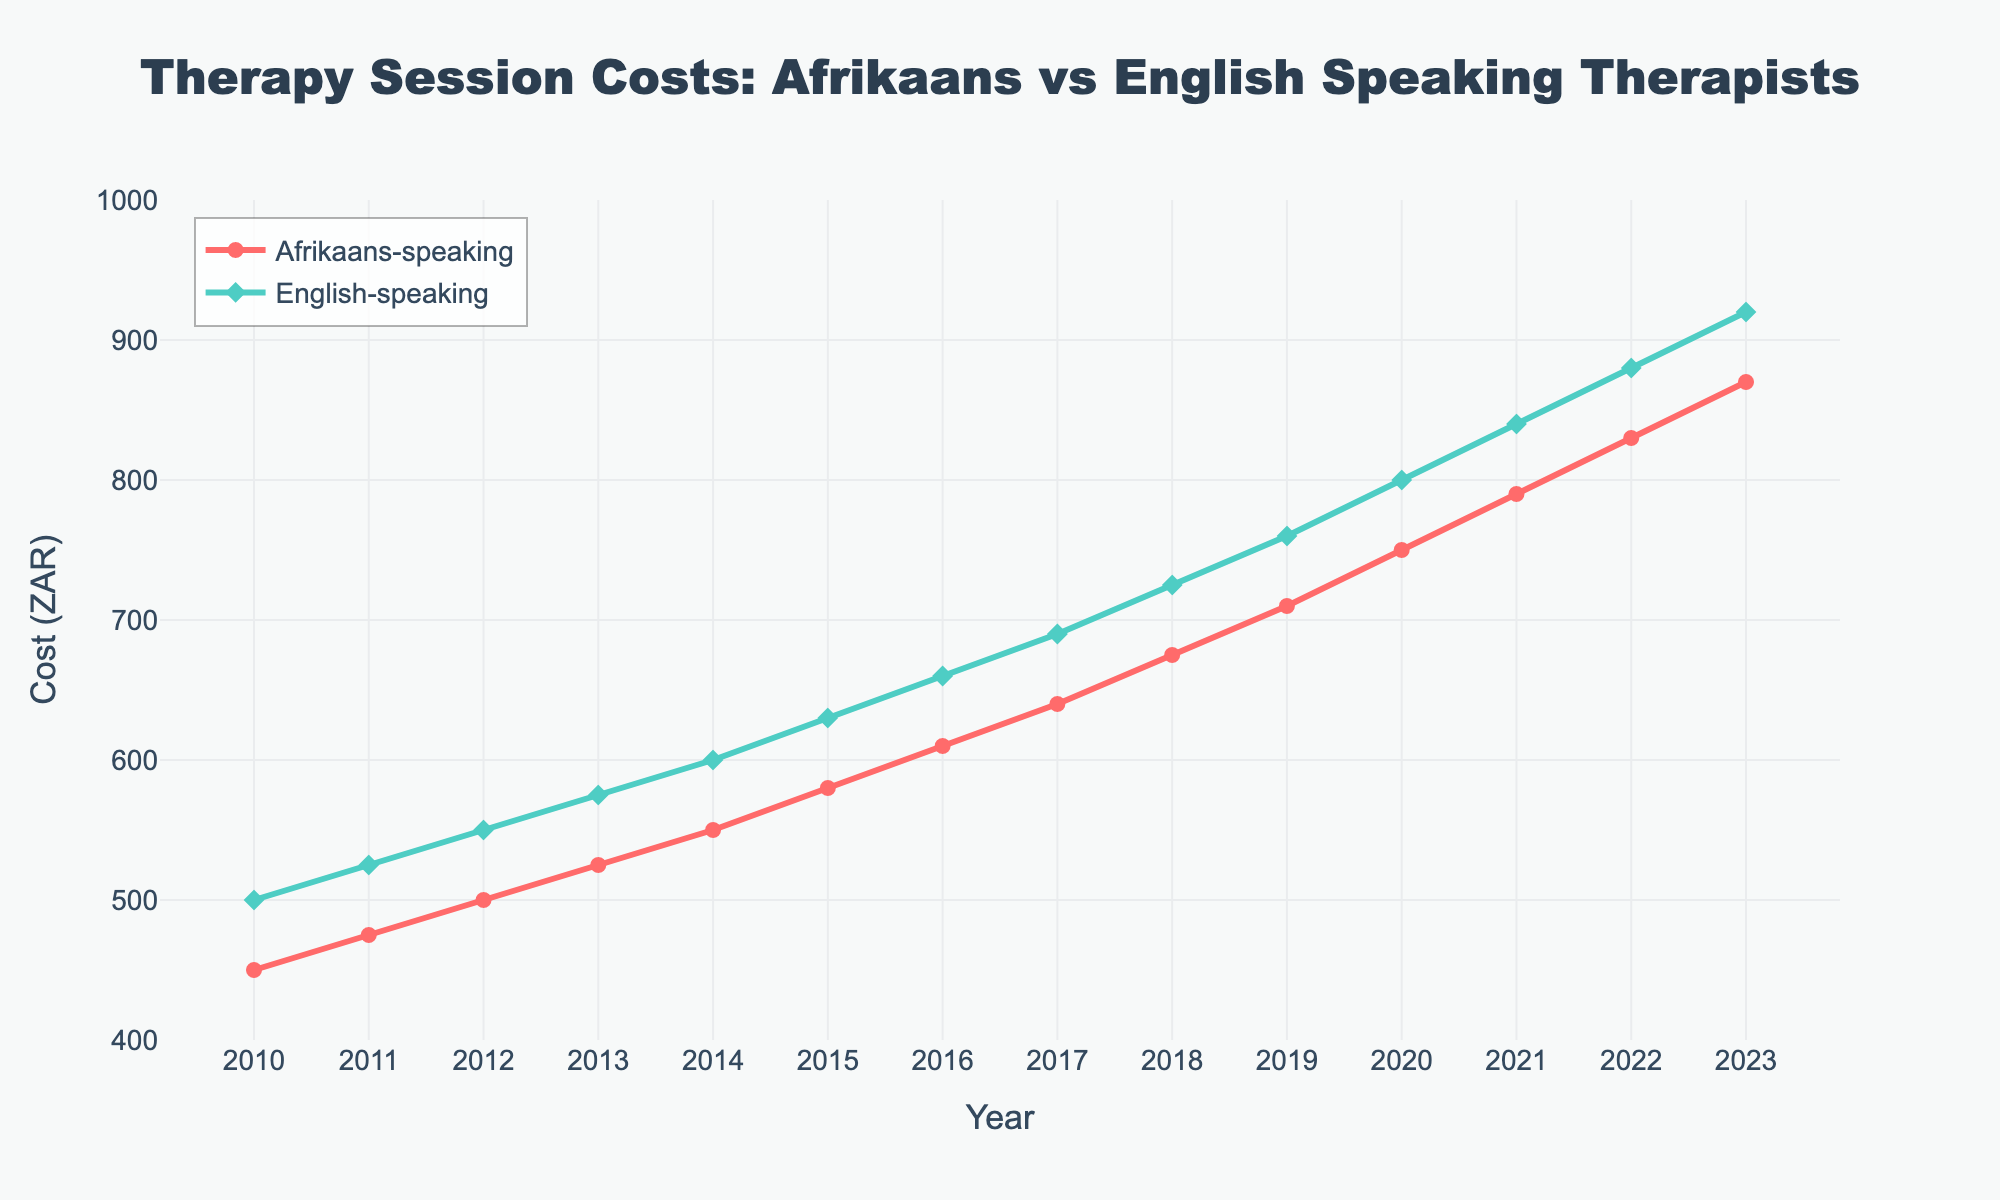What was the cost difference between Afrikaans-speaking therapists and English-speaking therapists in 2010? In 2010, the cost for Afrikaans-speaking therapists was 450 ZAR and for English-speaking therapists was 500 ZAR. The difference is 500 - 450 = 50 ZAR.
Answer: 50 ZAR Between which consecutive years did the cost for Afrikaans-speaking therapists increase the most? To answer this, check the year-on-year increments for Afrikaans-speaking therapists: 25 (2010-2011), 25 (2011-2012), 25 (2012-2013), 25 (2013-2014), 30 (2014-2015), 30 (2015-2016), 30 (2016-2017), 35 (2017-2018), 35 (2018-2019), 40 (2019-2020), 40 (2020-2021), 40 (2021-2022), 40 (2022-2023). The highest increment (40 ZAR) occurred between 2019-2020, 2020-2021, 2021-2022, and 2022-2023.
Answer: 2019-2020, 2020-2021, 2021-2022, 2022-2023 In which year were the costs for Afrikaans-speaking therapists and English-speaking therapists closest? Review the differences year by year: 50 (2010), 50 (2011), 50 (2012), 50 (2013), 50 (2014), 50 (2015), 50 (2016), 50 (2017), 50 (2018), 50 (2019), 50 (2020), 50 (2021), 50 (2022), 50 (2023). The costs were closest in every year as the difference is consistently 50 ZAR.
Answer: Every year What is the average cost for English-speaking therapists from 2010 to 2023? Add the yearly costs for English-speaking therapists and divide by the number of years: (500 + 525 + 550 + 575 + 600 + 630 + 660 + 690 + 725 + 760 + 800 + 840 + 880 + 920) / 14 = 11955 / 14 ≈ 854 ZAR.
Answer: 854 ZAR Which year had the highest cost for English-speaking therapists? The costs for English-speaking therapists increase each year, so the highest cost in 2023 is 920 ZAR.
Answer: 2023 How much did the cost for Afrikaans-speaking therapists grow from 2010 to 2023? Subtract the cost in 2010 from the cost in 2023: 870 - 450 = 420 ZAR.
Answer: 420 ZAR Which group had a higher cost in 2015, and by how much? In 2015, the cost for Afrikaans-speaking therapists was 580 ZAR, and for English-speaking therapists, it was 630 ZAR. The difference is 630 - 580 = 50 ZAR. English-speaking therapists cost 50 ZAR more.
Answer: English-speaking, 50 ZAR more From 2018 to 2023, how much did the cost for English-speaking therapists increase on average per year? First, find the total increase from 2018 to 2023: 920 - 725 = 195. Then divide by the number of years: 195 / 5 = 39 ZAR per year.
Answer: 39 ZAR per year 